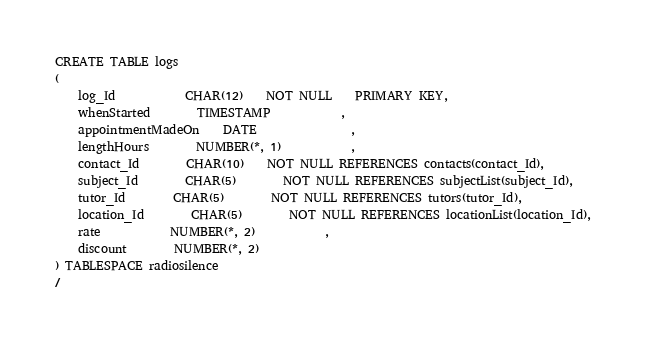Convert code to text. <code><loc_0><loc_0><loc_500><loc_500><_SQL_>CREATE TABLE logs
( 
	log_Id 			CHAR(12)	NOT NULL	PRIMARY KEY,
	whenStarted		TIMESTAMP			,
	appointmentMadeOn 	DATE				,
	lengthHours 	 	NUMBER(*, 1)			,
	contact_Id 		CHAR(10)	NOT NULL REFERENCES contacts(contact_Id),
	subject_Id 		CHAR(5)		NOT NULL REFERENCES subjectList(subject_Id),
	tutor_Id 		CHAR(5)		NOT NULL REFERENCES tutors(tutor_Id),
	location_Id 		CHAR(5)		NOT NULL REFERENCES locationList(location_Id),
	rate			NUMBER(*, 2)			,
	discount		NUMBER(*, 2)			
) TABLESPACE radiosilence
/
</code> 